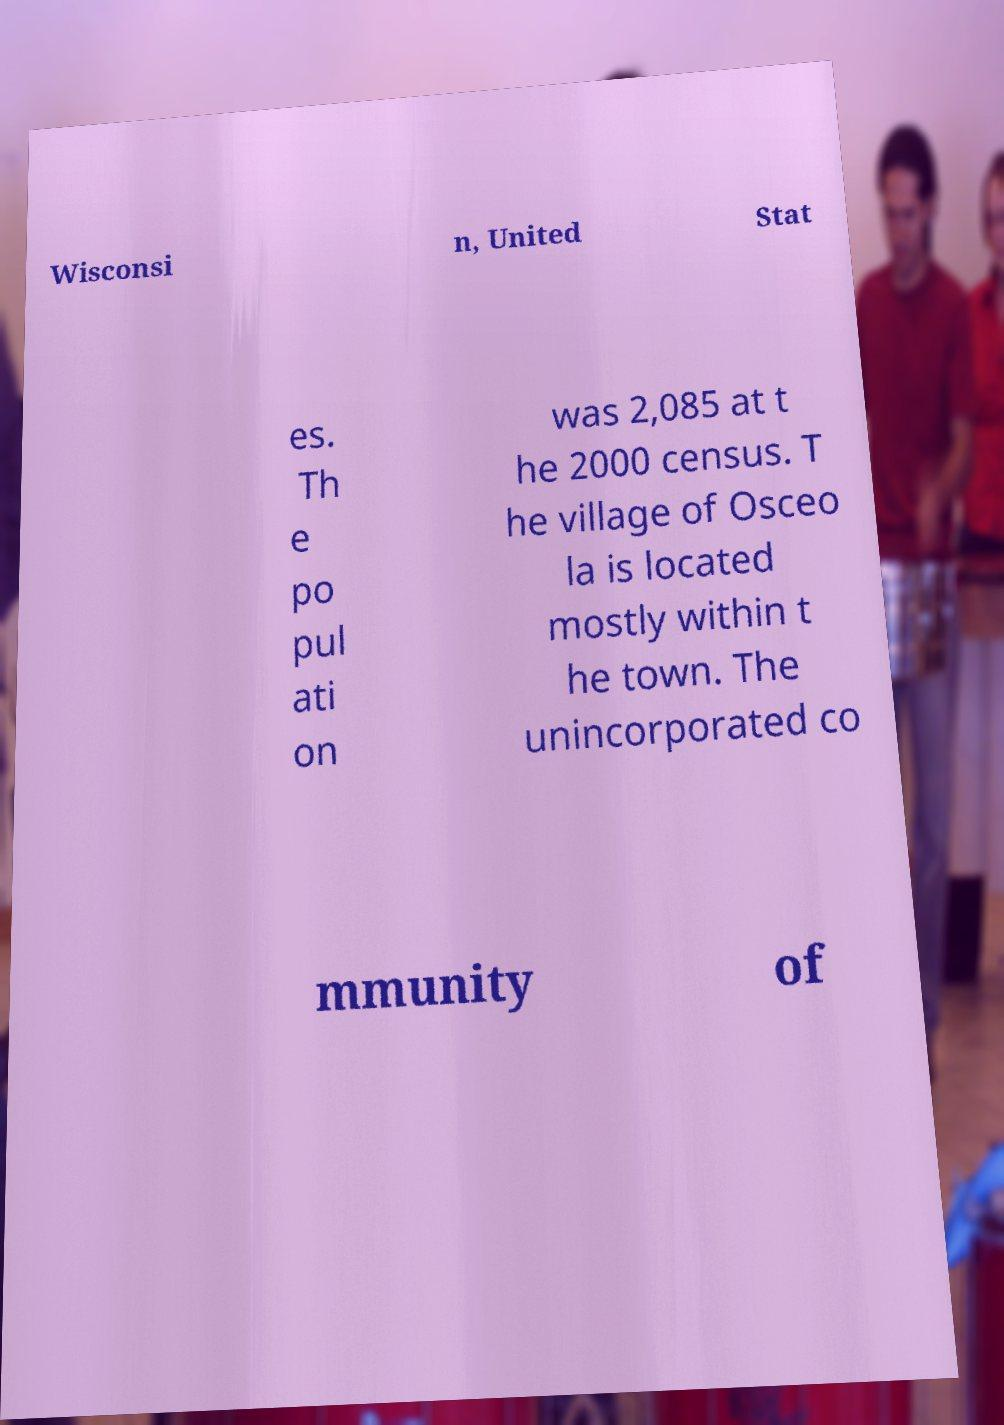I need the written content from this picture converted into text. Can you do that? Wisconsi n, United Stat es. Th e po pul ati on was 2,085 at t he 2000 census. T he village of Osceo la is located mostly within t he town. The unincorporated co mmunity of 